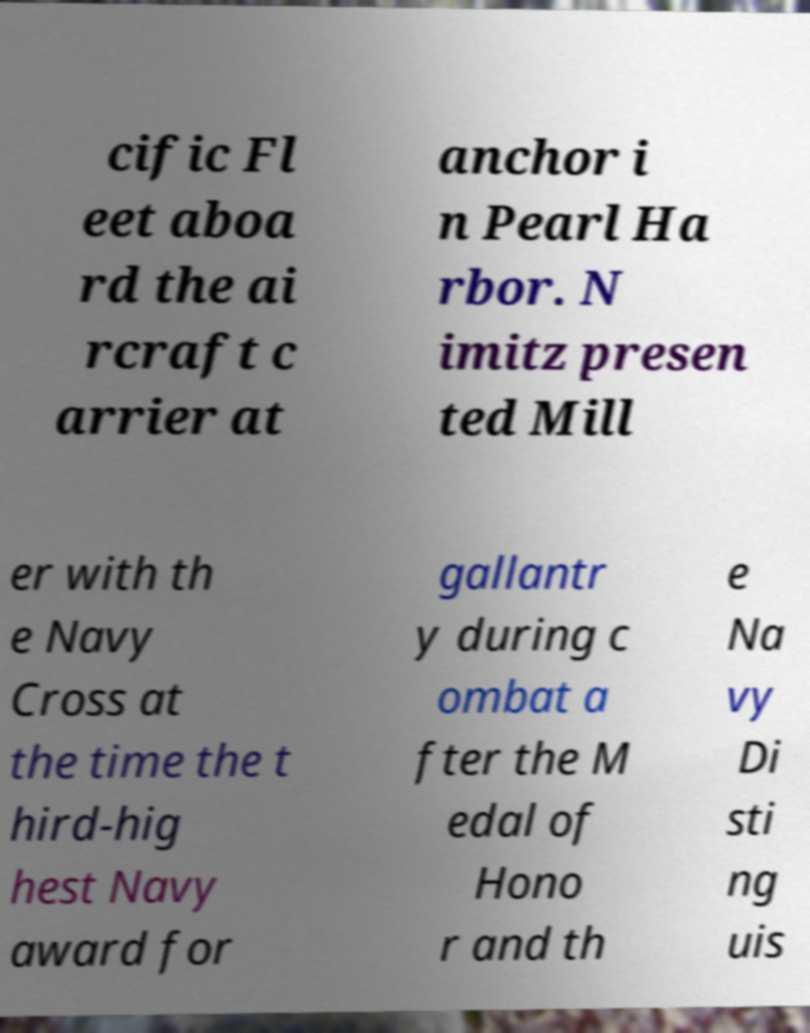For documentation purposes, I need the text within this image transcribed. Could you provide that? cific Fl eet aboa rd the ai rcraft c arrier at anchor i n Pearl Ha rbor. N imitz presen ted Mill er with th e Navy Cross at the time the t hird-hig hest Navy award for gallantr y during c ombat a fter the M edal of Hono r and th e Na vy Di sti ng uis 